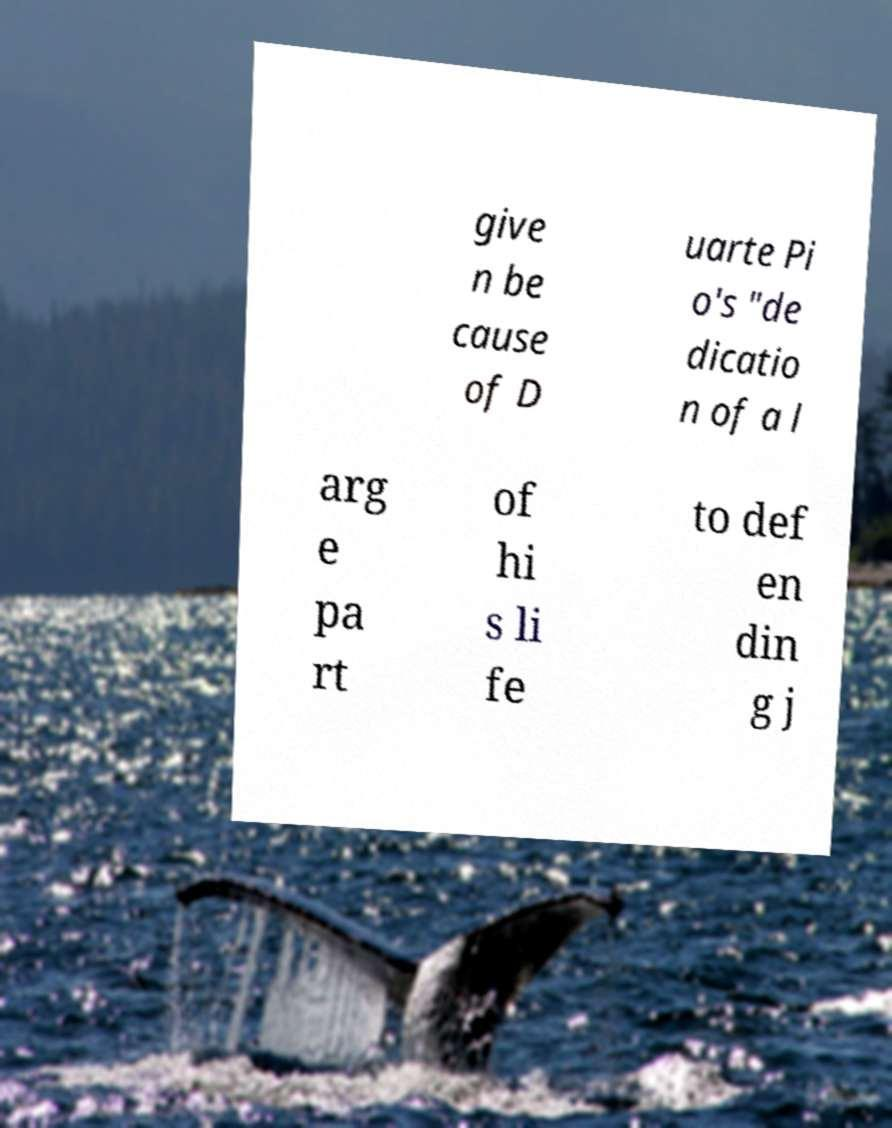Please read and relay the text visible in this image. What does it say? give n be cause of D uarte Pi o's "de dicatio n of a l arg e pa rt of hi s li fe to def en din g j 